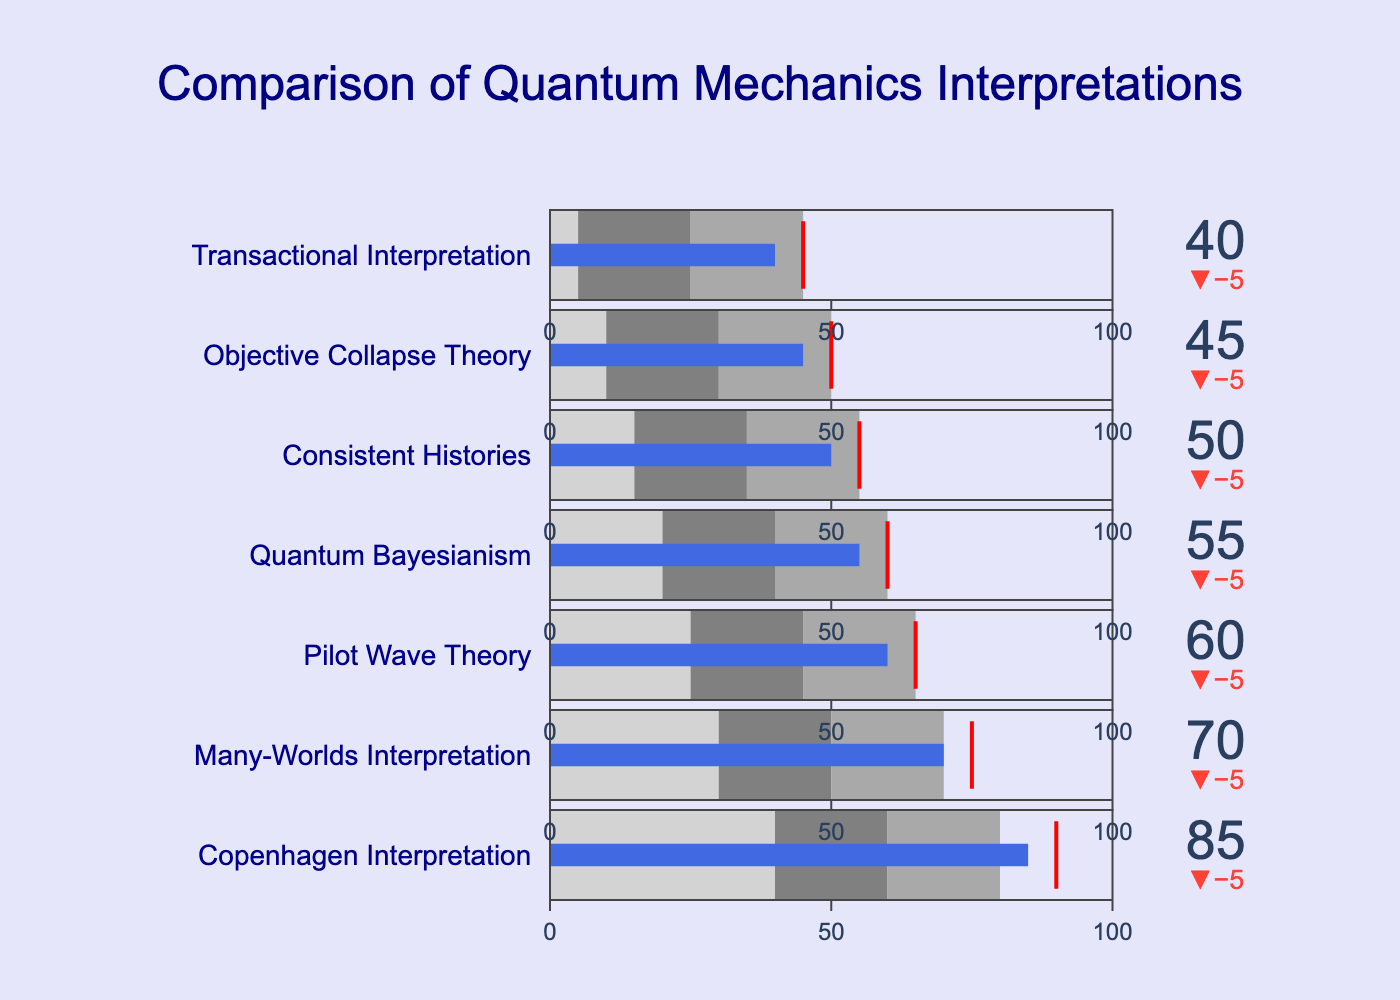What's the title of the figure? The title is located at the top of the figure in large font size, and it states the overall theme of the chart.
Answer: Comparison of Quantum Mechanics Interpretations Which interpretation of quantum mechanics has the highest experimental support? By looking at the actual values represented as blue bars, the Copenhagen Interpretation has the highest value.
Answer: Copenhagen Interpretation What is the bullet chart range for the Many-Worlds Interpretation? The steps of the gauge in the Many-Worlds Interpretation row show ranges. The light gray bar goes from 0-30, the gray bar from 30-50, and the dark gray bar from 50-70.
Answer: 0-30, 30-50, 50-70 Which interpretation has the smallest difference between the actual value and target value? The delta indicator next to the title of each row shows the difference. The smallest delta will have the minimum difference.
Answer: Transactional Interpretation How much lower is the Actual value of Pilot Wave Theory compared to its Target? The Pilot Wave Theory's delta value shows a negative difference which represents how actual value lags. The delta shows a -5 value indicating the difference.
Answer: 5 What's the average Actual value for the listed interpretations? Sum all actual values (85 + 70 + 60 + 55 + 50 + 45 + 40) and divide by the number of interpretations (7). So, (85+70+60+55+50+45+40)/7 = 405/7.
Answer: 57.86 Which interpretation has the closest actual value to the upper bound of its respective Range 3? Compare each interpretation's actual value with the value of their Range 3 upper bound. We find that the Copenhagen Interpretation has an actual value of 85 and its Range 3 upper bound is 80, making it the one closest to its upper bound.
Answer: Copenhagen Interpretation What can be inferred if an interpretation's actual value is within Range 3? If the actual value falls within Range 3, it indicates that it is in the 'dark gray' zone of support, meaning it has a high level of experimental support compared to interpretations falling into lower ranges.
Answer: High experimental support Which two interpretations have an actual value in the 'gray' support range? Check rows where the actual value falls into the second range (Range 2), which is the gray-colored range. Many-Worlds Interpretation and Pilot Wave Theory fall in the gray range.
Answer: Many-Worlds Interpretation, Pilot Wave Theory 